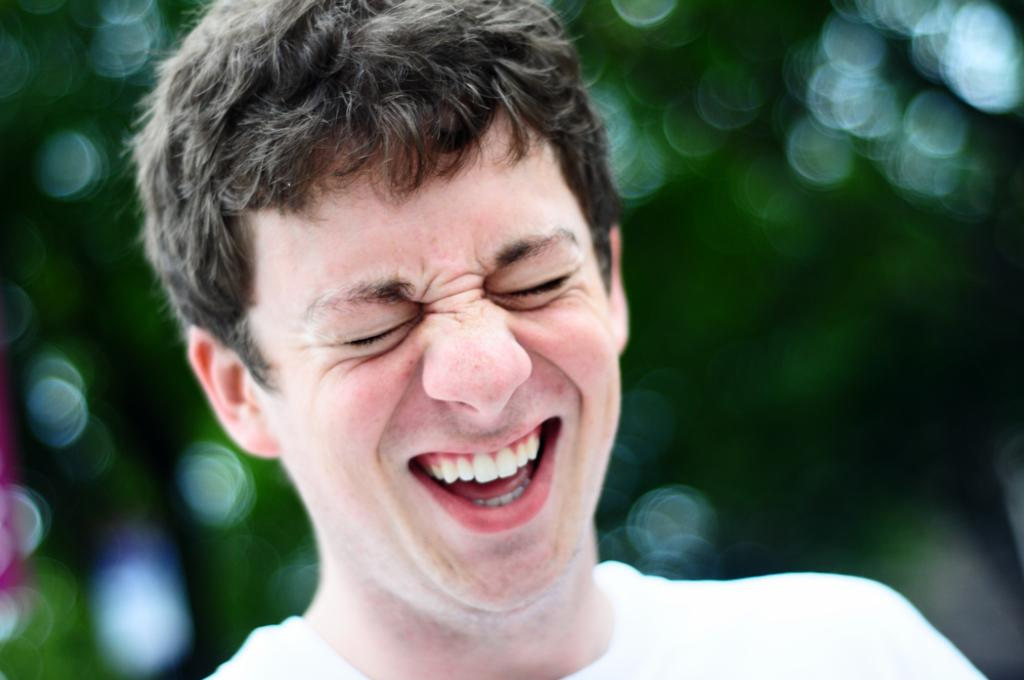Who is present in the image? There is a man in the picture. What is the man's facial expression? The man has a smile on his face. Can you describe the background of the image? The background of the image is blurry. What type of kitten can be seen opening the door in the image? There is no kitten or door present in the image; it features a man with a smile and a blurry background. What type of tramp is visible in the image? There is no tramp present in the image. 